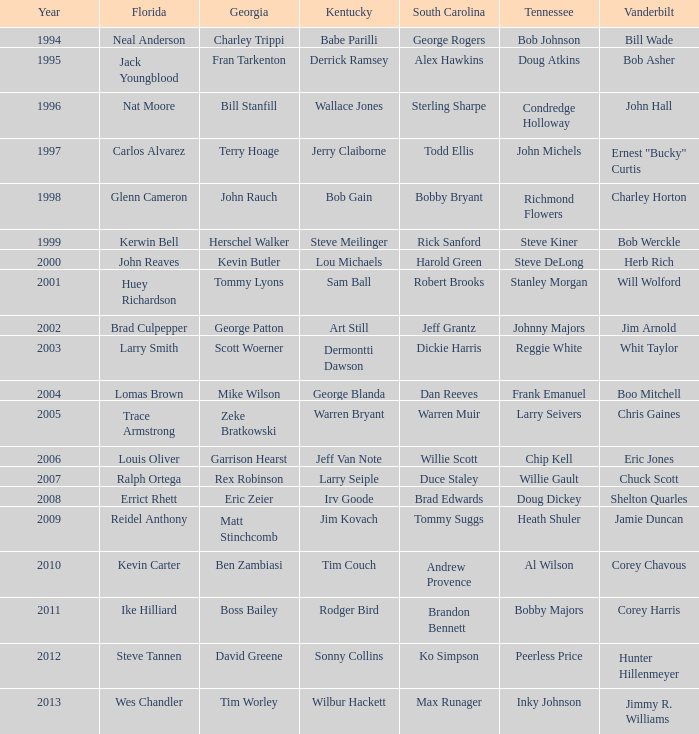How is larry seiple connected to both tennessee and kentucky? Willie Gault. 